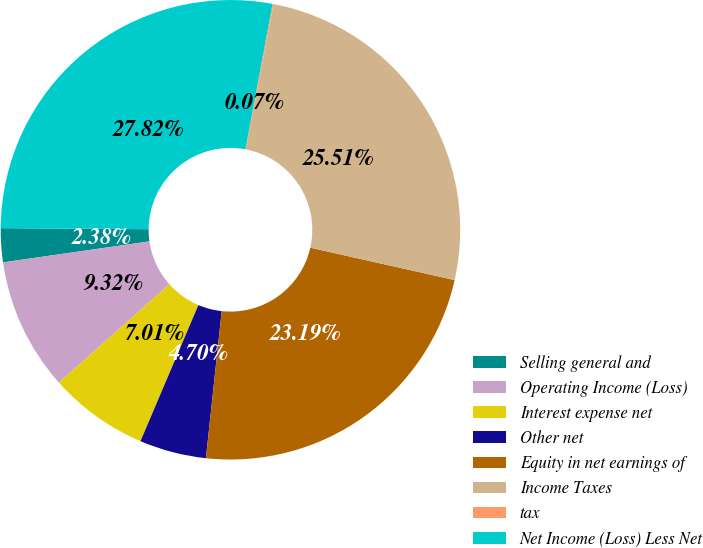Convert chart to OTSL. <chart><loc_0><loc_0><loc_500><loc_500><pie_chart><fcel>Selling general and<fcel>Operating Income (Loss)<fcel>Interest expense net<fcel>Other net<fcel>Equity in net earnings of<fcel>Income Taxes<fcel>tax<fcel>Net Income (Loss) Less Net<nl><fcel>2.38%<fcel>9.32%<fcel>7.01%<fcel>4.7%<fcel>23.19%<fcel>25.51%<fcel>0.07%<fcel>27.82%<nl></chart> 